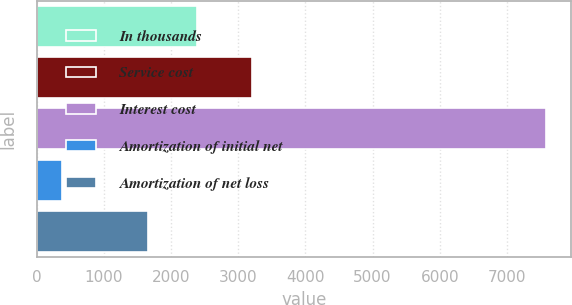<chart> <loc_0><loc_0><loc_500><loc_500><bar_chart><fcel>In thousands<fcel>Service cost<fcel>Interest cost<fcel>Amortization of initial net<fcel>Amortization of net loss<nl><fcel>2384.5<fcel>3204<fcel>7575<fcel>380<fcel>1665<nl></chart> 